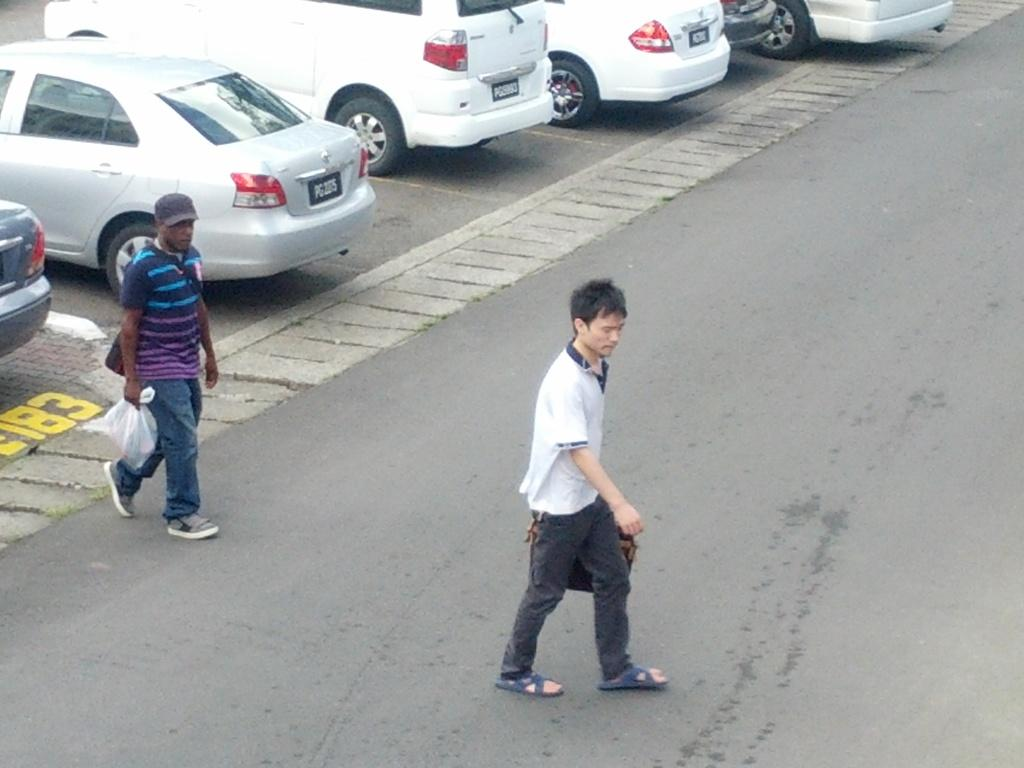How many people are in the image? There are two persons standing on the ground. What else can be seen on the ground besides the people? There are vehicles on the ground. What colors are the vehicles? The vehicles are grey and white in color. What type of channel can be seen running through the yard in the image? There is no yard or channel present in the image; it features two people and vehicles on the ground. 